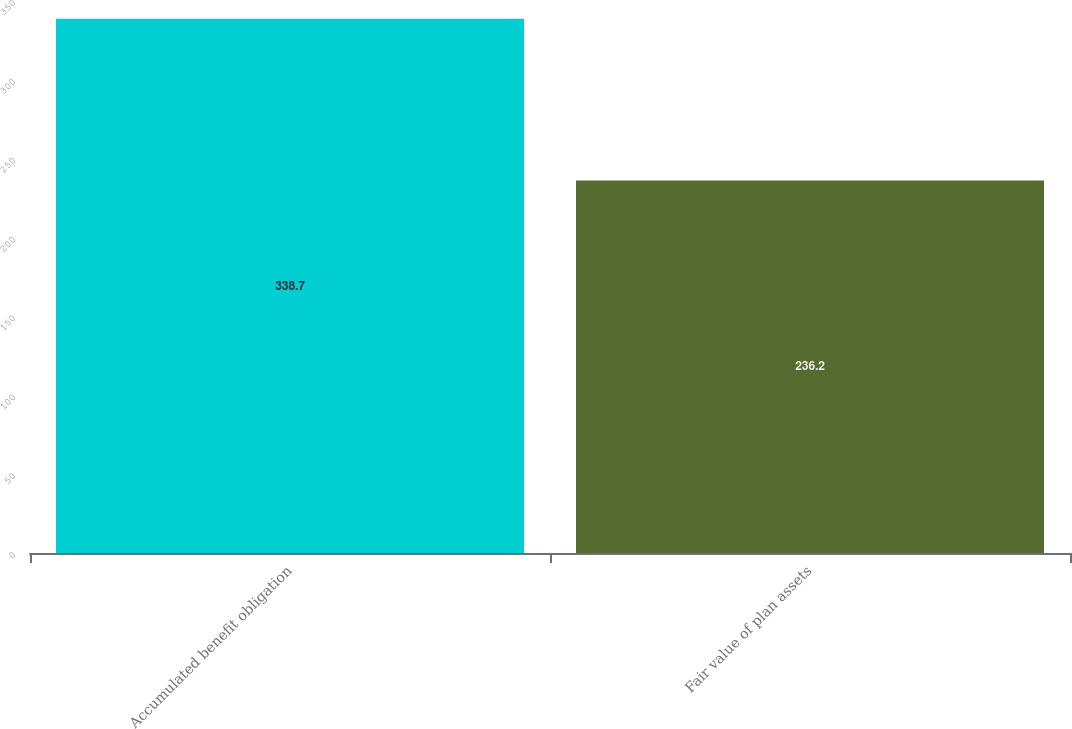Convert chart to OTSL. <chart><loc_0><loc_0><loc_500><loc_500><bar_chart><fcel>Accumulated benefit obligation<fcel>Fair value of plan assets<nl><fcel>338.7<fcel>236.2<nl></chart> 